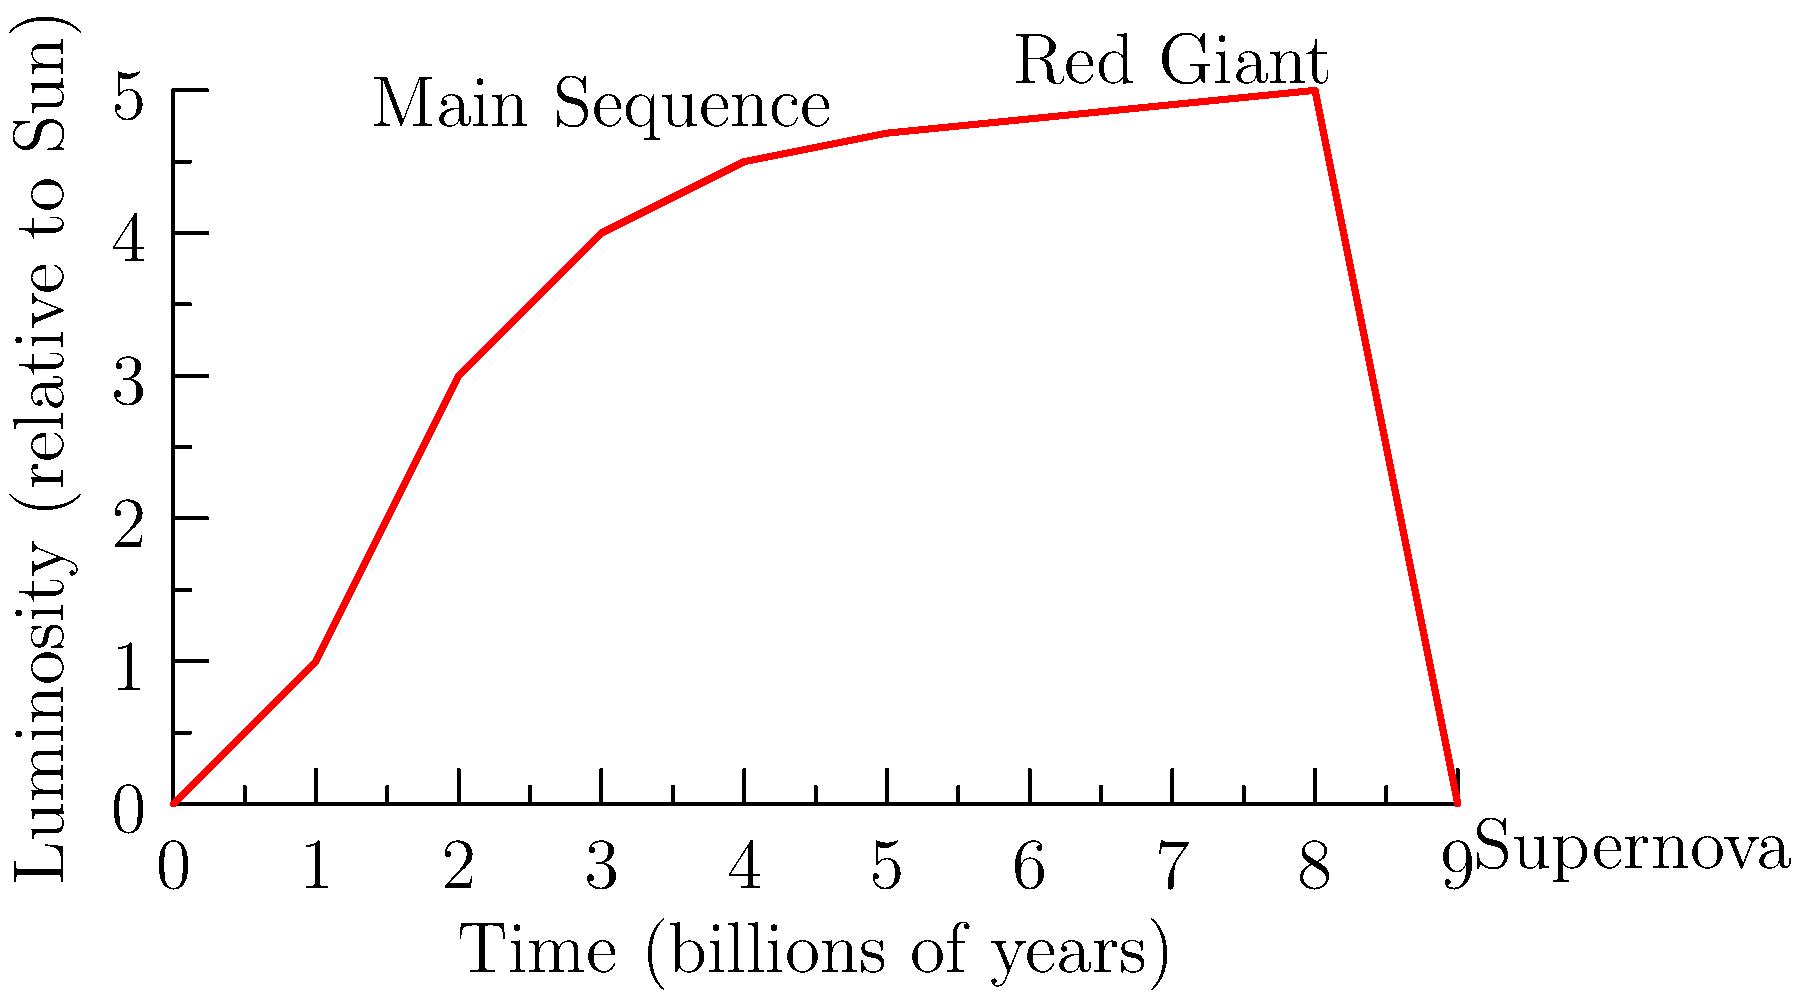As a PR manager skeptical of influencer marketing, you're tasked with creating an analogy between star life cycles and brand lifecycles. Given the graph showing a star's luminosity over time, which phase would best represent a brand's peak influence, and why might this be relevant to your skepticism of influencer marketing? To answer this question, let's break down the star's life cycle and draw parallels to brand lifecycles:

1. Main Sequence: This is the longest phase of a star's life, represented by the steady increase and plateau in the graph. For brands, this could be likened to steady growth and establishment in the market.

2. Red Giant: This phase shows a slight increase in luminosity near the end of the star's life. In brand terms, this could represent a period of renewed interest or a "second wind" for an established brand.

3. Supernova: The final, explosive phase where the star's luminosity spikes briefly before disappearing. For brands, this could be compared to a viral moment or a final, attention-grabbing campaign before potentially fading away.

The Red Giant phase would best represent a brand's peak influence because:

1. It occurs after a long period of stability (Main Sequence), suggesting a well-established reputation.
2. It shows increased luminosity (influence) beyond the normal levels.
3. It precedes the dramatic but short-lived Supernova phase.

This analogy is relevant to skepticism about influencer marketing because:

1. Influencer partnerships often aim for quick, Supernova-like spikes in attention, which may not lead to long-term brand value.
2. The most influential brands, like stars in the Red Giant phase, have typically built their reputation over time rather than through short-term collaborations.
3. The graph shows that the majority of a star's life (and by analogy, a brand's life) is spent in the steady Main Sequence phase, suggesting that consistent, long-term strategies may be more effective than quick-fix influencer campaigns.
Answer: Red Giant phase; it represents sustained influence built over time, contrasting with short-term influencer marketing effects. 